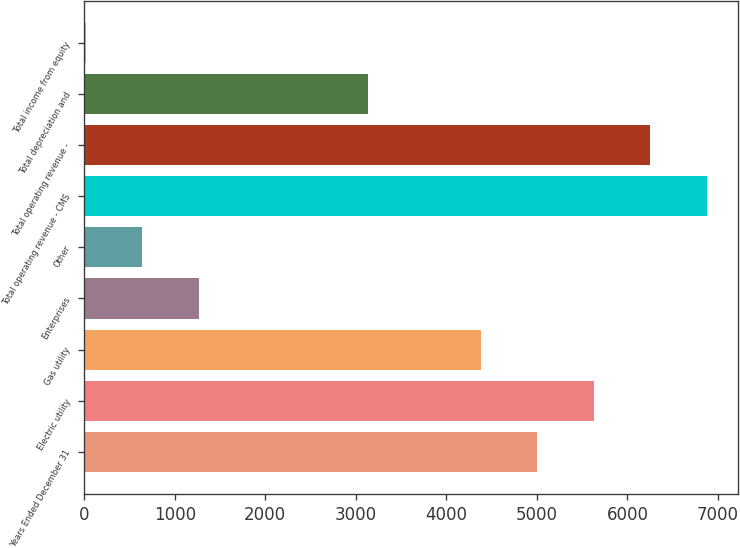Convert chart. <chart><loc_0><loc_0><loc_500><loc_500><bar_chart><fcel>Years Ended December 31<fcel>Electric utility<fcel>Gas utility<fcel>Enterprises<fcel>Other<fcel>Total operating revenue - CMS<fcel>Total operating revenue -<fcel>Total depreciation and<fcel>Total income from equity<nl><fcel>5005.8<fcel>5629.4<fcel>4382.2<fcel>1264.2<fcel>640.6<fcel>6876.6<fcel>6253<fcel>3135<fcel>17<nl></chart> 